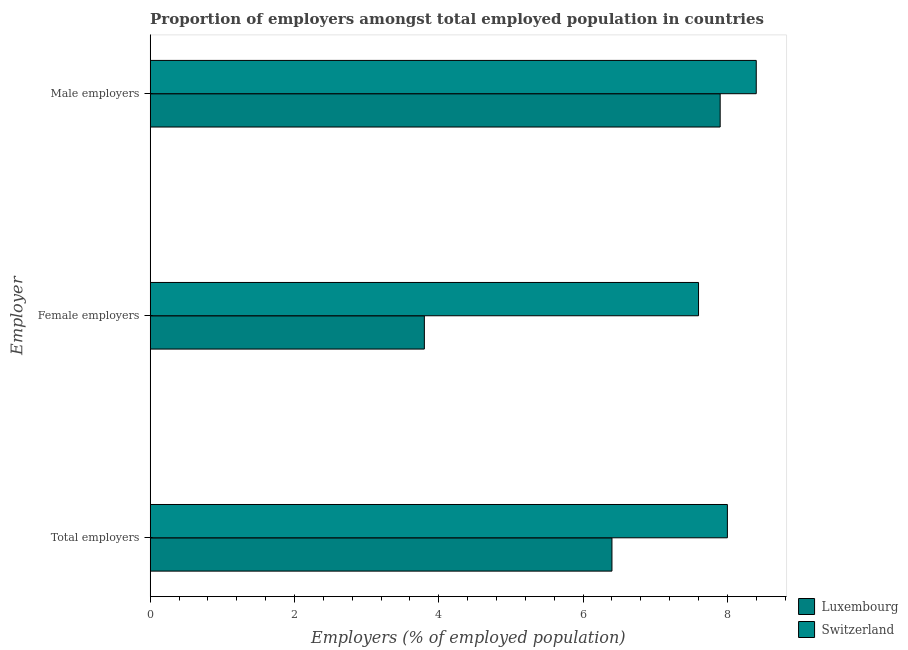How many different coloured bars are there?
Offer a very short reply. 2. How many bars are there on the 2nd tick from the top?
Offer a terse response. 2. How many bars are there on the 2nd tick from the bottom?
Make the answer very short. 2. What is the label of the 2nd group of bars from the top?
Your answer should be very brief. Female employers. What is the percentage of male employers in Luxembourg?
Give a very brief answer. 7.9. Across all countries, what is the maximum percentage of male employers?
Your answer should be compact. 8.4. Across all countries, what is the minimum percentage of female employers?
Ensure brevity in your answer.  3.8. In which country was the percentage of male employers maximum?
Your answer should be compact. Switzerland. In which country was the percentage of total employers minimum?
Give a very brief answer. Luxembourg. What is the total percentage of female employers in the graph?
Ensure brevity in your answer.  11.4. What is the difference between the percentage of male employers in Luxembourg and that in Switzerland?
Your response must be concise. -0.5. What is the difference between the percentage of female employers in Switzerland and the percentage of total employers in Luxembourg?
Keep it short and to the point. 1.2. What is the average percentage of female employers per country?
Make the answer very short. 5.7. What is the difference between the percentage of female employers and percentage of total employers in Luxembourg?
Your answer should be compact. -2.6. What is the ratio of the percentage of total employers in Switzerland to that in Luxembourg?
Provide a short and direct response. 1.25. Is the difference between the percentage of male employers in Switzerland and Luxembourg greater than the difference between the percentage of female employers in Switzerland and Luxembourg?
Your response must be concise. No. What is the difference between the highest and the second highest percentage of male employers?
Your answer should be compact. 0.5. What is the difference between the highest and the lowest percentage of male employers?
Offer a terse response. 0.5. Is the sum of the percentage of male employers in Switzerland and Luxembourg greater than the maximum percentage of total employers across all countries?
Ensure brevity in your answer.  Yes. What does the 2nd bar from the top in Male employers represents?
Your answer should be very brief. Luxembourg. What does the 2nd bar from the bottom in Male employers represents?
Offer a very short reply. Switzerland. Is it the case that in every country, the sum of the percentage of total employers and percentage of female employers is greater than the percentage of male employers?
Provide a short and direct response. Yes. Are the values on the major ticks of X-axis written in scientific E-notation?
Offer a very short reply. No. How many legend labels are there?
Ensure brevity in your answer.  2. How are the legend labels stacked?
Your answer should be compact. Vertical. What is the title of the graph?
Keep it short and to the point. Proportion of employers amongst total employed population in countries. Does "Fiji" appear as one of the legend labels in the graph?
Your response must be concise. No. What is the label or title of the X-axis?
Ensure brevity in your answer.  Employers (% of employed population). What is the label or title of the Y-axis?
Provide a short and direct response. Employer. What is the Employers (% of employed population) in Luxembourg in Total employers?
Keep it short and to the point. 6.4. What is the Employers (% of employed population) in Luxembourg in Female employers?
Provide a short and direct response. 3.8. What is the Employers (% of employed population) of Switzerland in Female employers?
Ensure brevity in your answer.  7.6. What is the Employers (% of employed population) of Luxembourg in Male employers?
Your answer should be very brief. 7.9. What is the Employers (% of employed population) in Switzerland in Male employers?
Your answer should be very brief. 8.4. Across all Employer, what is the maximum Employers (% of employed population) of Luxembourg?
Give a very brief answer. 7.9. Across all Employer, what is the maximum Employers (% of employed population) in Switzerland?
Your answer should be compact. 8.4. Across all Employer, what is the minimum Employers (% of employed population) of Luxembourg?
Your response must be concise. 3.8. Across all Employer, what is the minimum Employers (% of employed population) in Switzerland?
Keep it short and to the point. 7.6. What is the difference between the Employers (% of employed population) in Luxembourg in Total employers and that in Male employers?
Provide a short and direct response. -1.5. What is the difference between the Employers (% of employed population) in Luxembourg in Female employers and that in Male employers?
Make the answer very short. -4.1. What is the difference between the Employers (% of employed population) in Luxembourg in Total employers and the Employers (% of employed population) in Switzerland in Male employers?
Make the answer very short. -2. What is the difference between the Employers (% of employed population) in Luxembourg in Female employers and the Employers (% of employed population) in Switzerland in Male employers?
Ensure brevity in your answer.  -4.6. What is the average Employers (% of employed population) in Luxembourg per Employer?
Give a very brief answer. 6.03. What is the average Employers (% of employed population) in Switzerland per Employer?
Give a very brief answer. 8. What is the difference between the Employers (% of employed population) of Luxembourg and Employers (% of employed population) of Switzerland in Total employers?
Your answer should be very brief. -1.6. What is the difference between the Employers (% of employed population) of Luxembourg and Employers (% of employed population) of Switzerland in Female employers?
Keep it short and to the point. -3.8. What is the ratio of the Employers (% of employed population) in Luxembourg in Total employers to that in Female employers?
Keep it short and to the point. 1.68. What is the ratio of the Employers (% of employed population) in Switzerland in Total employers to that in Female employers?
Your answer should be very brief. 1.05. What is the ratio of the Employers (% of employed population) of Luxembourg in Total employers to that in Male employers?
Make the answer very short. 0.81. What is the ratio of the Employers (% of employed population) in Luxembourg in Female employers to that in Male employers?
Give a very brief answer. 0.48. What is the ratio of the Employers (% of employed population) of Switzerland in Female employers to that in Male employers?
Offer a terse response. 0.9. What is the difference between the highest and the second highest Employers (% of employed population) in Luxembourg?
Your answer should be compact. 1.5. What is the difference between the highest and the lowest Employers (% of employed population) of Switzerland?
Offer a terse response. 0.8. 